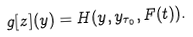Convert formula to latex. <formula><loc_0><loc_0><loc_500><loc_500>g [ z ] ( y ) = H ( y , y _ { \tau _ { 0 } } , F ( t ) ) .</formula> 